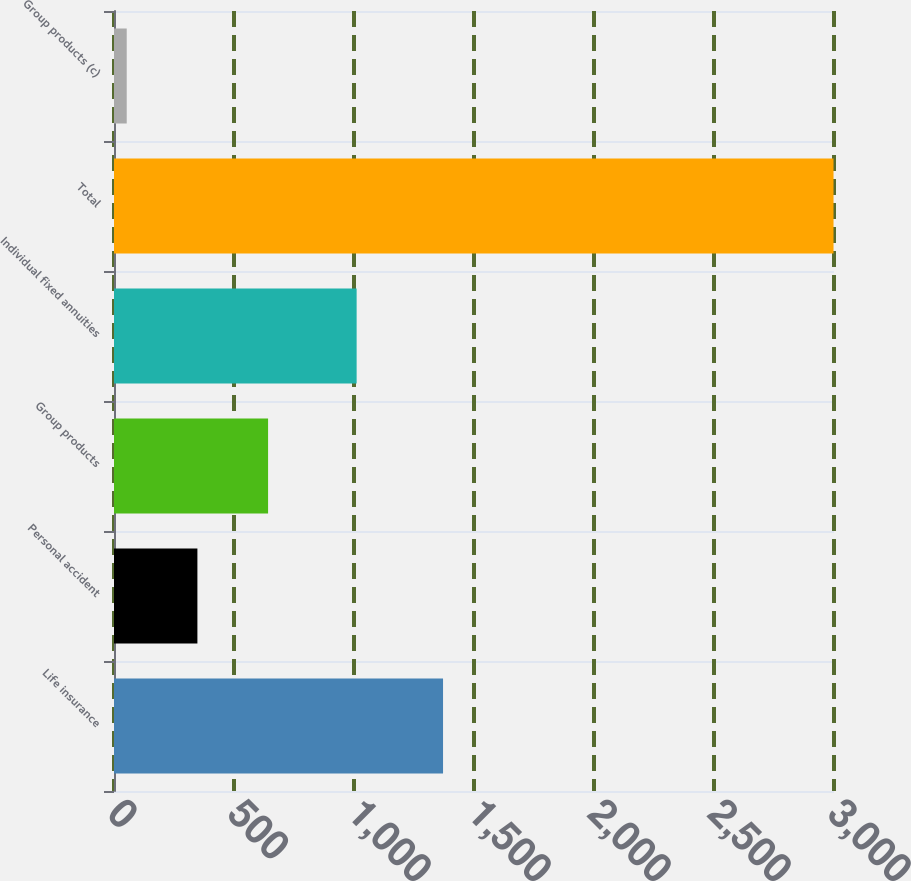Convert chart. <chart><loc_0><loc_0><loc_500><loc_500><bar_chart><fcel>Life insurance<fcel>Personal accident<fcel>Group products<fcel>Individual fixed annuities<fcel>Total<fcel>Group products (c)<nl><fcel>1371<fcel>347.5<fcel>642<fcel>1011<fcel>2998<fcel>53<nl></chart> 